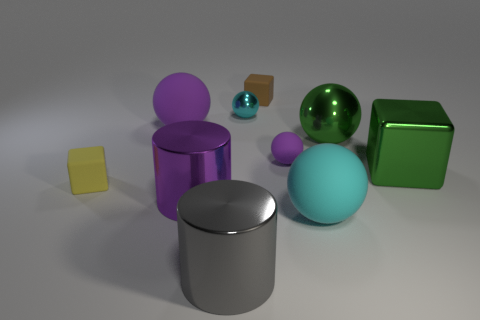Subtract all green shiny blocks. How many blocks are left? 2 Subtract all green balls. How many balls are left? 4 Subtract 1 cylinders. How many cylinders are left? 1 Subtract all cubes. How many objects are left? 7 Subtract all green spheres. How many purple cylinders are left? 1 Subtract all small yellow things. Subtract all matte blocks. How many objects are left? 7 Add 9 tiny brown matte cubes. How many tiny brown matte cubes are left? 10 Add 1 red cylinders. How many red cylinders exist? 1 Subtract 0 purple cubes. How many objects are left? 10 Subtract all brown balls. Subtract all purple blocks. How many balls are left? 5 